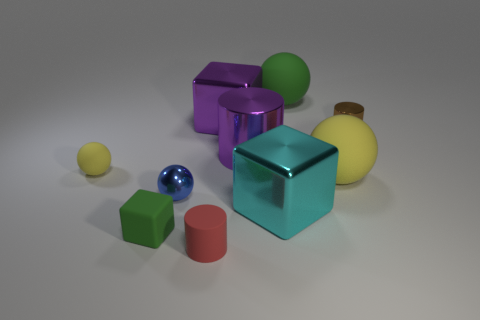Do the brown thing and the blue metal sphere have the same size? While the blue metal sphere and the brown object, which appears to be a corked bottle, do not share the same geometric shape, their sizes seem quite comparable. Given the difference in their shapes, a precise size comparison is challenging, but visually, they seem to be of similar dimensions. 